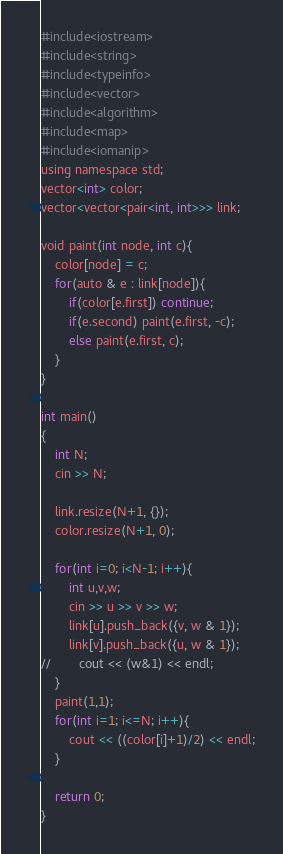Convert code to text. <code><loc_0><loc_0><loc_500><loc_500><_Awk_>#include<iostream>
#include<string>
#include<typeinfo>
#include<vector>
#include<algorithm>
#include<map>
#include<iomanip>
using namespace std;
vector<int> color;
vector<vector<pair<int, int>>> link;

void paint(int node, int c){
	color[node] = c;
	for(auto & e : link[node]){
		if(color[e.first]) continue;
		if(e.second) paint(e.first, -c);
		else paint(e.first, c);
	}
}

int main()
{
	int N;
	cin >> N;

	link.resize(N+1, {});
	color.resize(N+1, 0);

	for(int i=0; i<N-1; i++){
		int u,v,w;
		cin >> u >> v >> w;
		link[u].push_back({v, w & 1});
		link[v].push_back({u, w & 1});
//		cout << (w&1) << endl;
	}
	paint(1,1);
	for(int i=1; i<=N; i++){
		cout << ((color[i]+1)/2) << endl;
	}

	return 0;
}</code> 